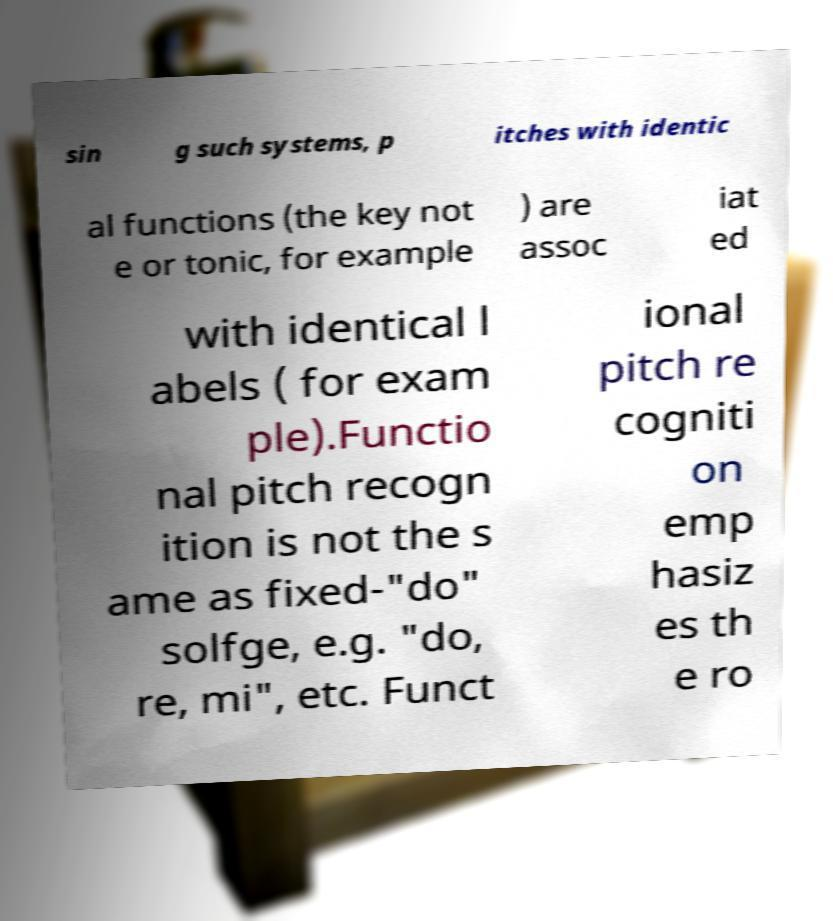Please identify and transcribe the text found in this image. sin g such systems, p itches with identic al functions (the key not e or tonic, for example ) are assoc iat ed with identical l abels ( for exam ple).Functio nal pitch recogn ition is not the s ame as fixed-"do" solfge, e.g. "do, re, mi", etc. Funct ional pitch re cogniti on emp hasiz es th e ro 